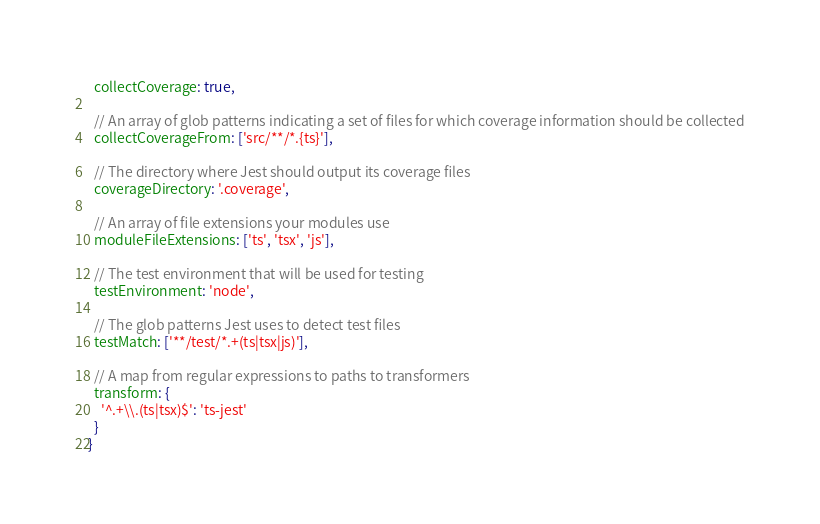<code> <loc_0><loc_0><loc_500><loc_500><_JavaScript_>  collectCoverage: true,

  // An array of glob patterns indicating a set of files for which coverage information should be collected
  collectCoverageFrom: ['src/**/*.{ts}'],

  // The directory where Jest should output its coverage files
  coverageDirectory: '.coverage',

  // An array of file extensions your modules use
  moduleFileExtensions: ['ts', 'tsx', 'js'],

  // The test environment that will be used for testing
  testEnvironment: 'node',

  // The glob patterns Jest uses to detect test files
  testMatch: ['**/test/*.+(ts|tsx|js)'],

  // A map from regular expressions to paths to transformers
  transform: {
    '^.+\\.(ts|tsx)$': 'ts-jest'
  }
}
</code> 